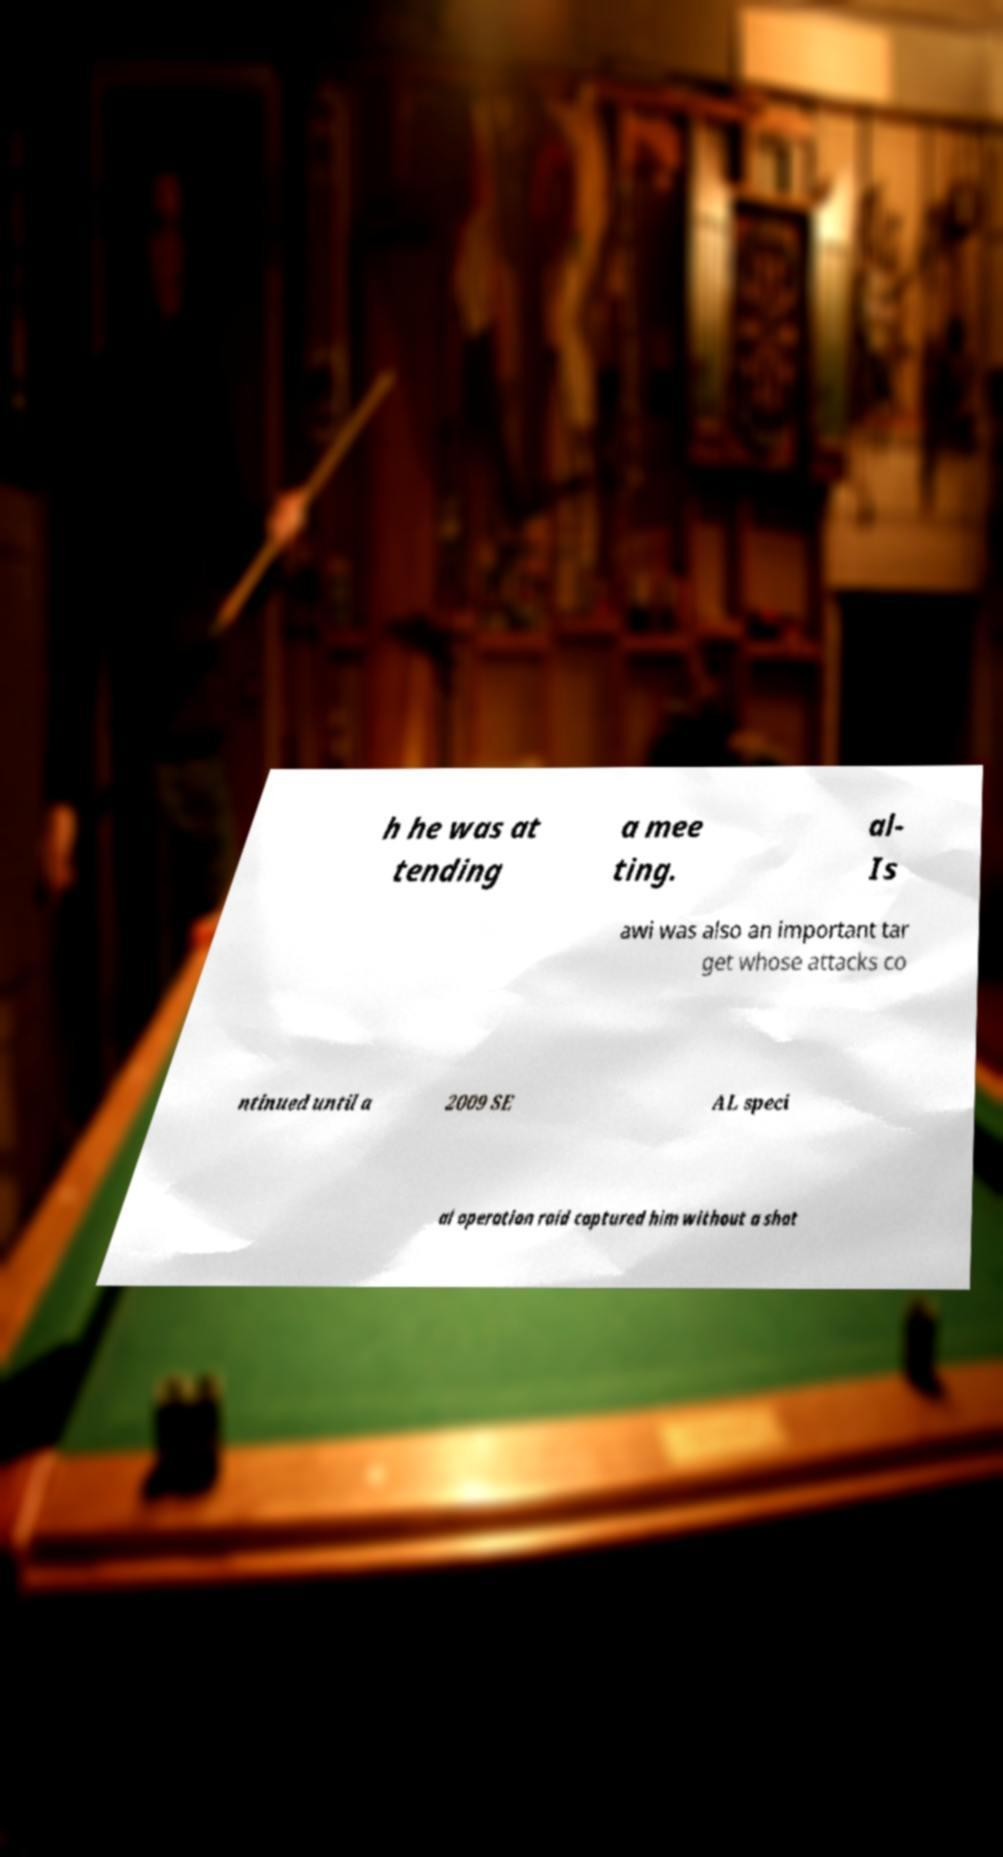For documentation purposes, I need the text within this image transcribed. Could you provide that? h he was at tending a mee ting. al- Is awi was also an important tar get whose attacks co ntinued until a 2009 SE AL speci al operation raid captured him without a shot 